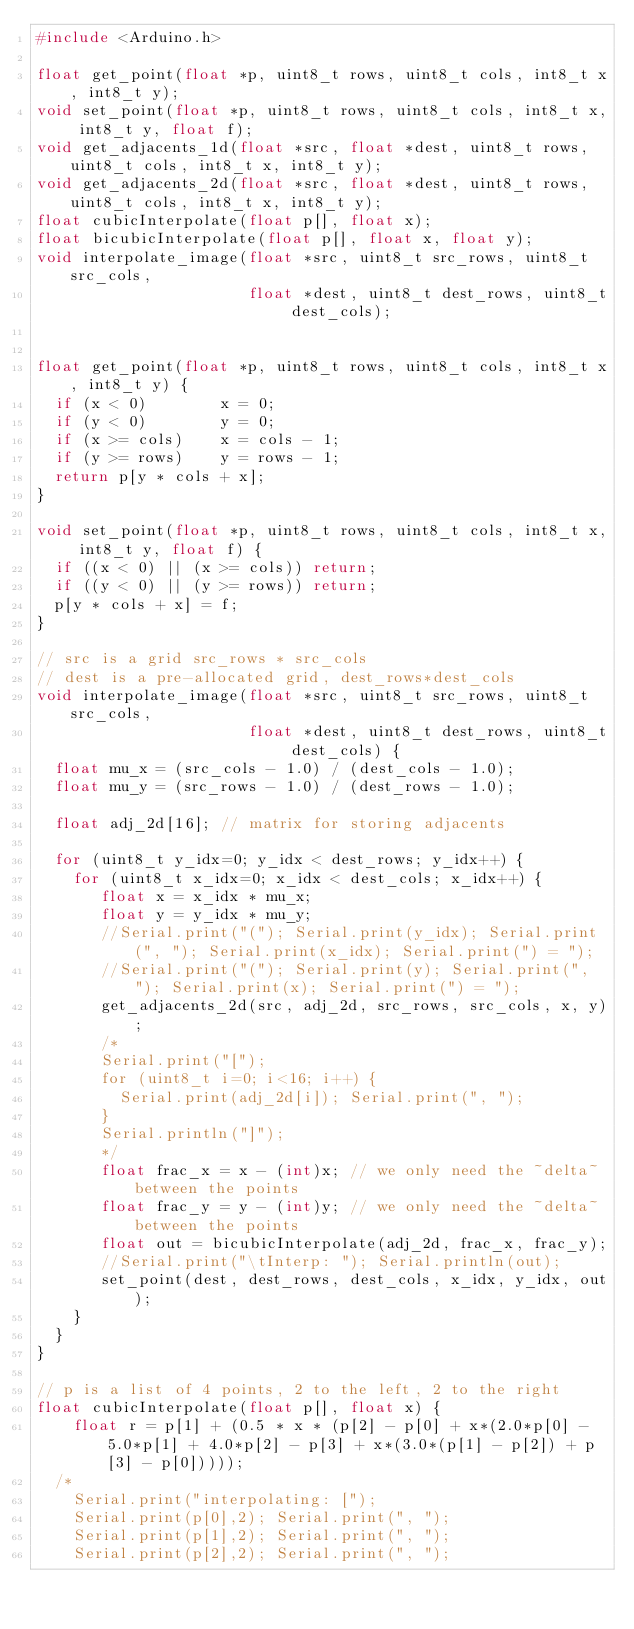<code> <loc_0><loc_0><loc_500><loc_500><_C++_>#include <Arduino.h>

float get_point(float *p, uint8_t rows, uint8_t cols, int8_t x, int8_t y);
void set_point(float *p, uint8_t rows, uint8_t cols, int8_t x, int8_t y, float f);
void get_adjacents_1d(float *src, float *dest, uint8_t rows, uint8_t cols, int8_t x, int8_t y);
void get_adjacents_2d(float *src, float *dest, uint8_t rows, uint8_t cols, int8_t x, int8_t y);
float cubicInterpolate(float p[], float x);
float bicubicInterpolate(float p[], float x, float y);
void interpolate_image(float *src, uint8_t src_rows, uint8_t src_cols, 
                       float *dest, uint8_t dest_rows, uint8_t dest_cols);


float get_point(float *p, uint8_t rows, uint8_t cols, int8_t x, int8_t y) {
  if (x < 0)        x = 0;
  if (y < 0)        y = 0;
  if (x >= cols)    x = cols - 1;
  if (y >= rows)    y = rows - 1;
  return p[y * cols + x];
}

void set_point(float *p, uint8_t rows, uint8_t cols, int8_t x, int8_t y, float f) {
  if ((x < 0) || (x >= cols)) return;
  if ((y < 0) || (y >= rows)) return;
  p[y * cols + x] = f;
}

// src is a grid src_rows * src_cols
// dest is a pre-allocated grid, dest_rows*dest_cols
void interpolate_image(float *src, uint8_t src_rows, uint8_t src_cols, 
                       float *dest, uint8_t dest_rows, uint8_t dest_cols) {
  float mu_x = (src_cols - 1.0) / (dest_cols - 1.0);
  float mu_y = (src_rows - 1.0) / (dest_rows - 1.0);

  float adj_2d[16]; // matrix for storing adjacents
  
  for (uint8_t y_idx=0; y_idx < dest_rows; y_idx++) {
    for (uint8_t x_idx=0; x_idx < dest_cols; x_idx++) {
       float x = x_idx * mu_x;
       float y = y_idx * mu_y;
       //Serial.print("("); Serial.print(y_idx); Serial.print(", "); Serial.print(x_idx); Serial.print(") = ");
       //Serial.print("("); Serial.print(y); Serial.print(", "); Serial.print(x); Serial.print(") = ");
       get_adjacents_2d(src, adj_2d, src_rows, src_cols, x, y);
       /*
       Serial.print("[");
       for (uint8_t i=0; i<16; i++) {
         Serial.print(adj_2d[i]); Serial.print(", ");
       }
       Serial.println("]");
       */
       float frac_x = x - (int)x; // we only need the ~delta~ between the points
       float frac_y = y - (int)y; // we only need the ~delta~ between the points
       float out = bicubicInterpolate(adj_2d, frac_x, frac_y);
       //Serial.print("\tInterp: "); Serial.println(out);
       set_point(dest, dest_rows, dest_cols, x_idx, y_idx, out);
    }
  }
}

// p is a list of 4 points, 2 to the left, 2 to the right
float cubicInterpolate(float p[], float x) {
    float r = p[1] + (0.5 * x * (p[2] - p[0] + x*(2.0*p[0] - 5.0*p[1] + 4.0*p[2] - p[3] + x*(3.0*(p[1] - p[2]) + p[3] - p[0]))));
  /*
    Serial.print("interpolating: ["); 
    Serial.print(p[0],2); Serial.print(", ");
    Serial.print(p[1],2); Serial.print(", ");
    Serial.print(p[2],2); Serial.print(", ");</code> 